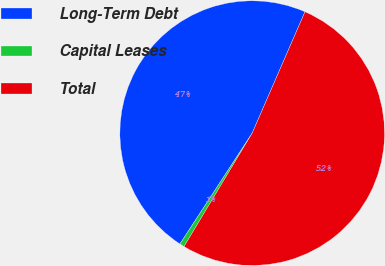Convert chart to OTSL. <chart><loc_0><loc_0><loc_500><loc_500><pie_chart><fcel>Long-Term Debt<fcel>Capital Leases<fcel>Total<nl><fcel>47.34%<fcel>0.58%<fcel>52.08%<nl></chart> 